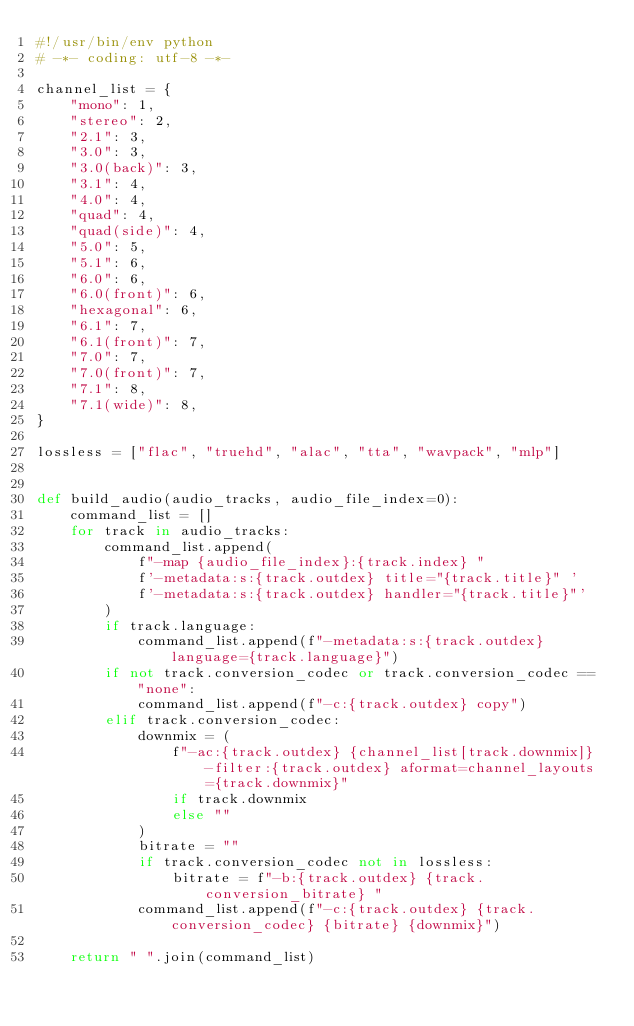<code> <loc_0><loc_0><loc_500><loc_500><_Python_>#!/usr/bin/env python
# -*- coding: utf-8 -*-

channel_list = {
    "mono": 1,
    "stereo": 2,
    "2.1": 3,
    "3.0": 3,
    "3.0(back)": 3,
    "3.1": 4,
    "4.0": 4,
    "quad": 4,
    "quad(side)": 4,
    "5.0": 5,
    "5.1": 6,
    "6.0": 6,
    "6.0(front)": 6,
    "hexagonal": 6,
    "6.1": 7,
    "6.1(front)": 7,
    "7.0": 7,
    "7.0(front)": 7,
    "7.1": 8,
    "7.1(wide)": 8,
}

lossless = ["flac", "truehd", "alac", "tta", "wavpack", "mlp"]


def build_audio(audio_tracks, audio_file_index=0):
    command_list = []
    for track in audio_tracks:
        command_list.append(
            f"-map {audio_file_index}:{track.index} "
            f'-metadata:s:{track.outdex} title="{track.title}" '
            f'-metadata:s:{track.outdex} handler="{track.title}"'
        )
        if track.language:
            command_list.append(f"-metadata:s:{track.outdex} language={track.language}")
        if not track.conversion_codec or track.conversion_codec == "none":
            command_list.append(f"-c:{track.outdex} copy")
        elif track.conversion_codec:
            downmix = (
                f"-ac:{track.outdex} {channel_list[track.downmix]} -filter:{track.outdex} aformat=channel_layouts={track.downmix}"
                if track.downmix
                else ""
            )
            bitrate = ""
            if track.conversion_codec not in lossless:
                bitrate = f"-b:{track.outdex} {track.conversion_bitrate} "
            command_list.append(f"-c:{track.outdex} {track.conversion_codec} {bitrate} {downmix}")

    return " ".join(command_list)
</code> 